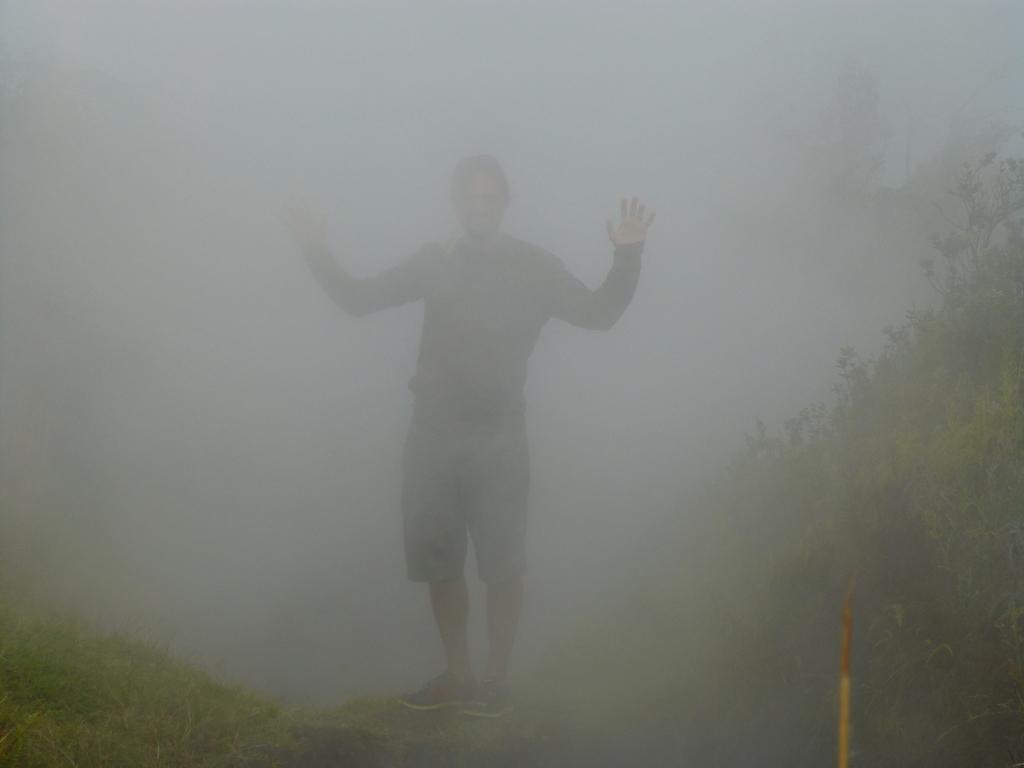How would you summarize this image in a sentence or two? In the center of the image there is a person standing. There is grass at the bottom of the image. 